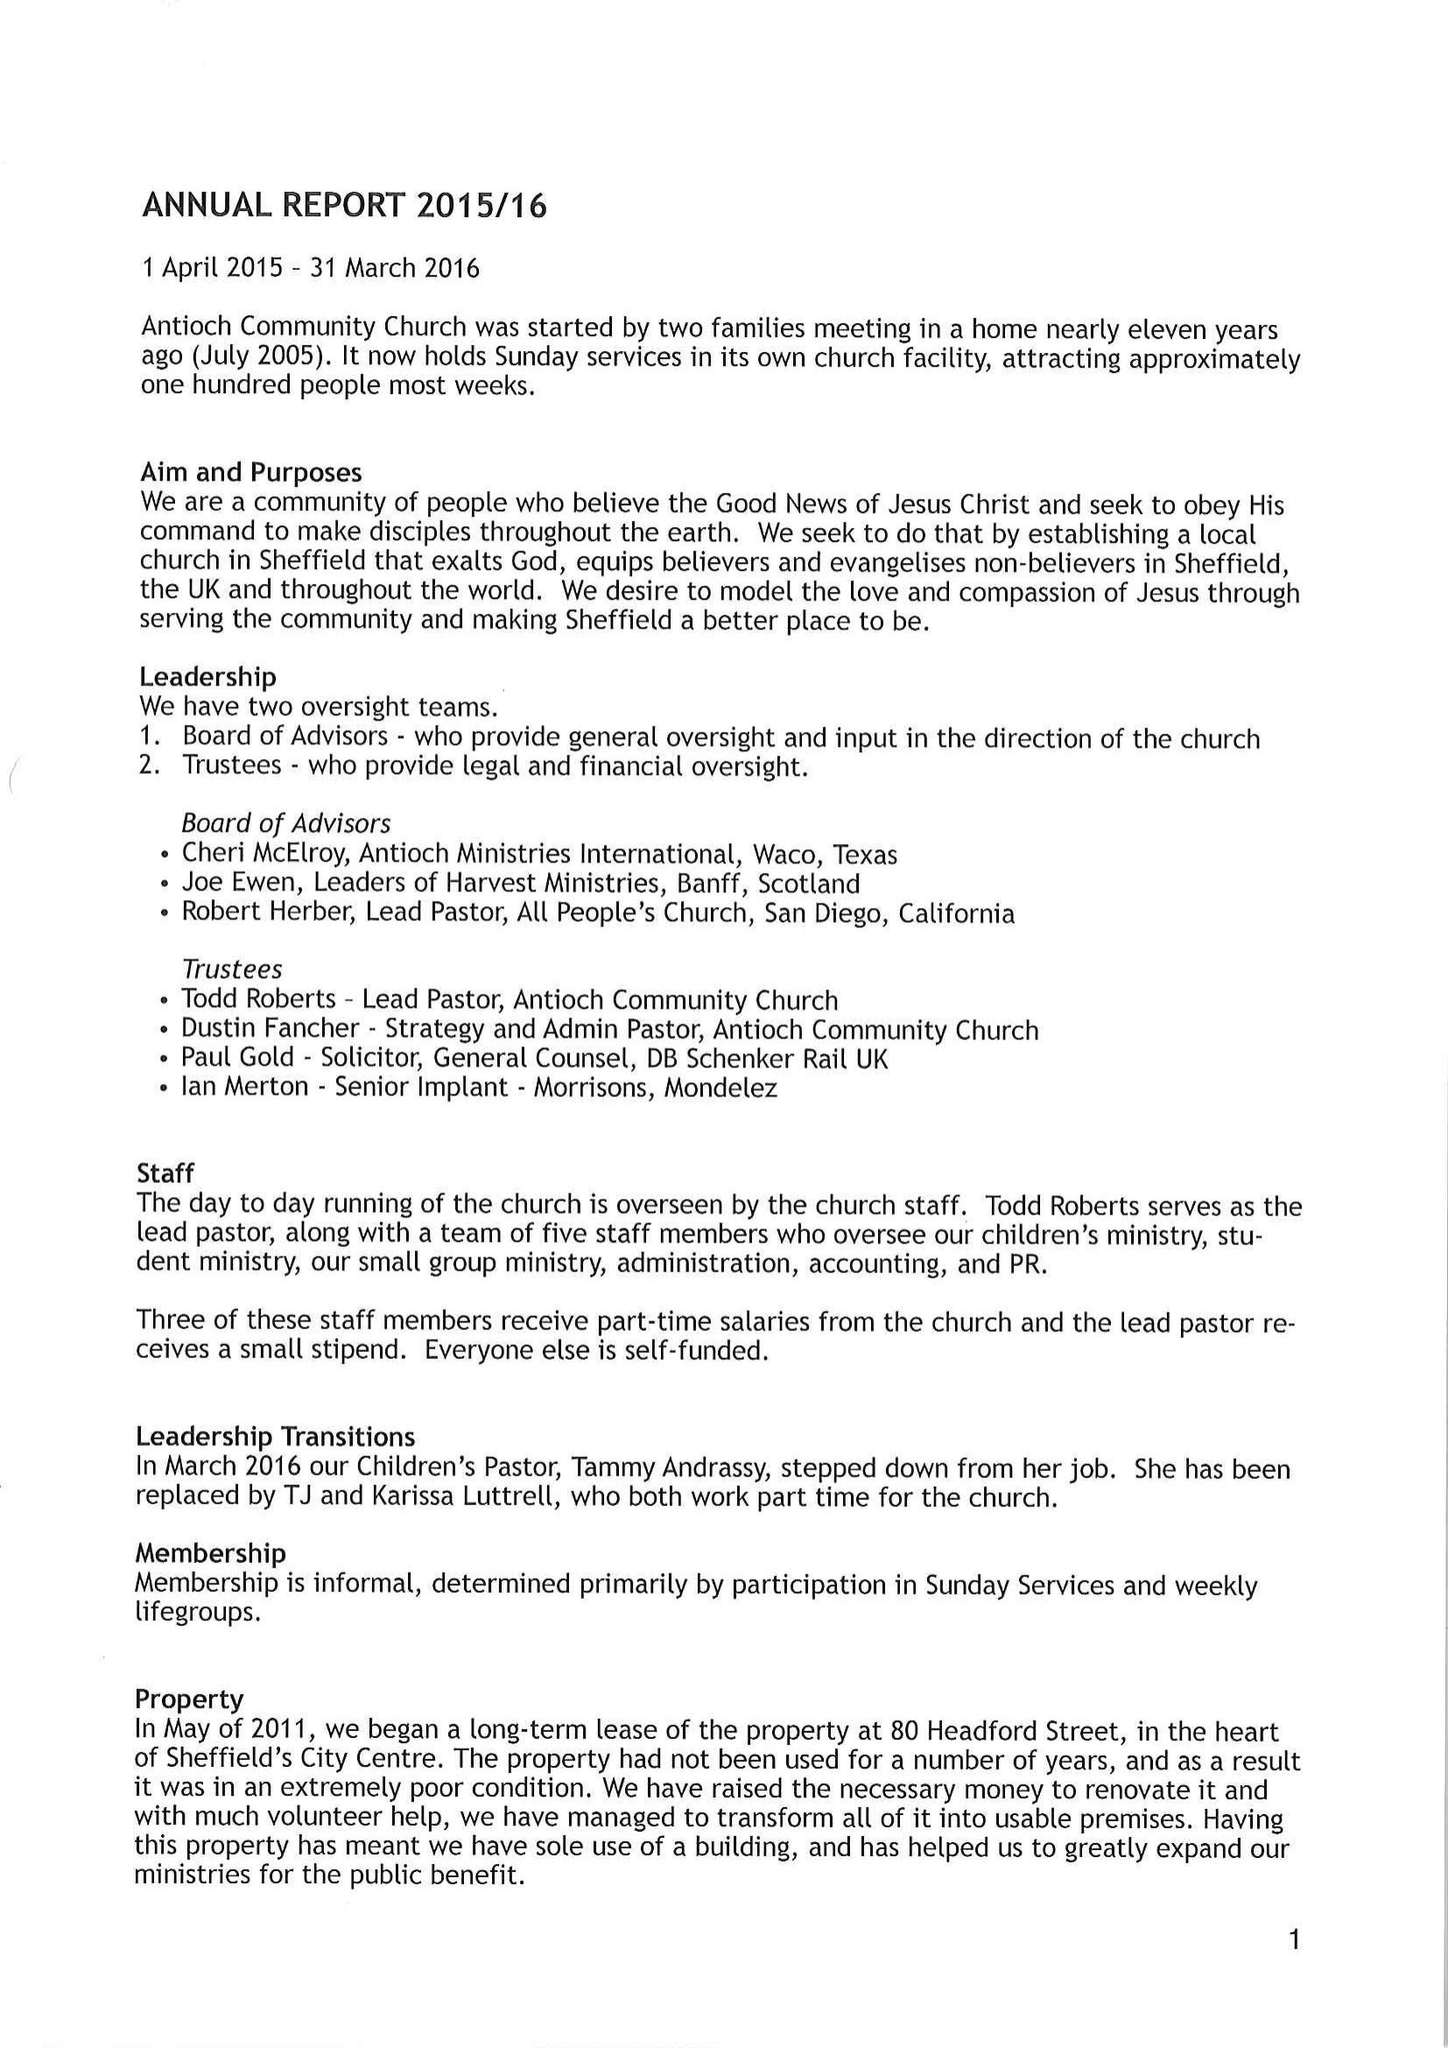What is the value for the report_date?
Answer the question using a single word or phrase. 2016-03-31 